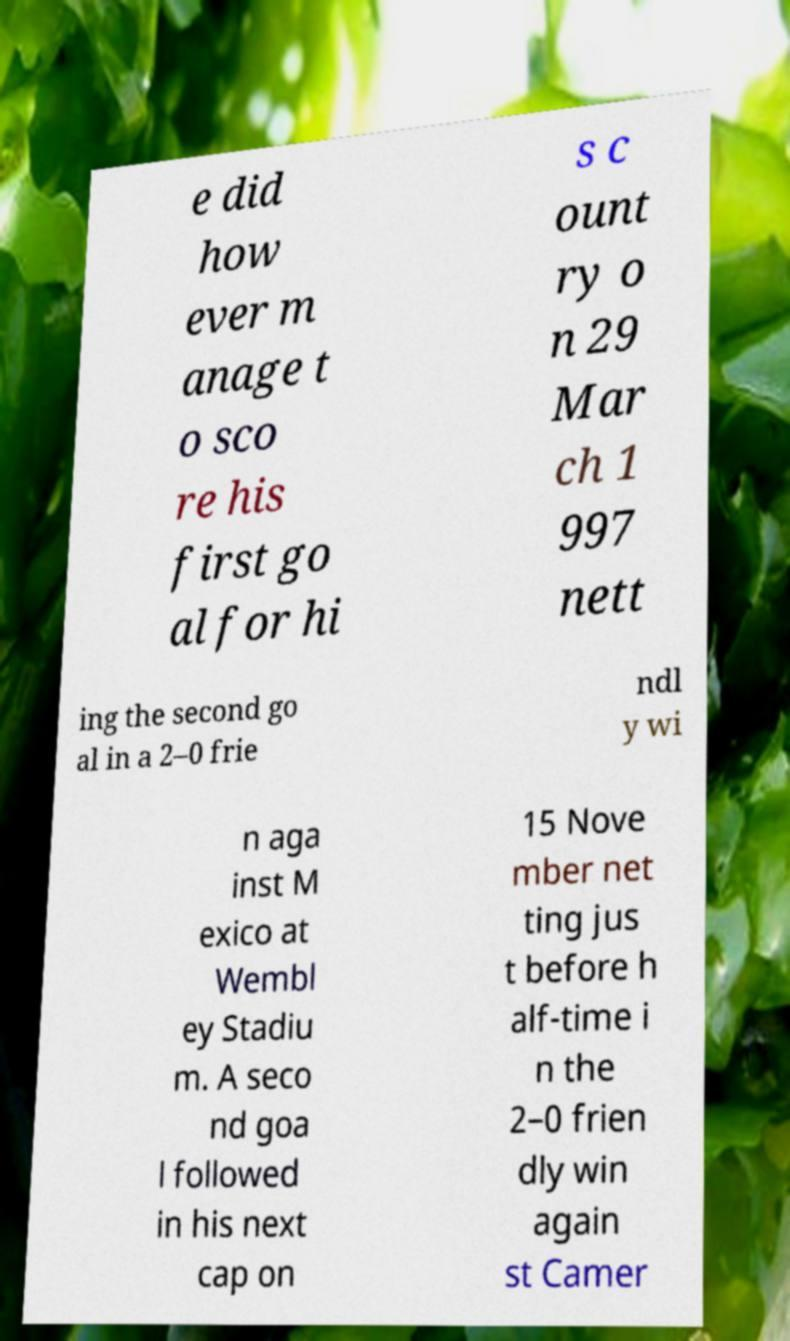For documentation purposes, I need the text within this image transcribed. Could you provide that? e did how ever m anage t o sco re his first go al for hi s c ount ry o n 29 Mar ch 1 997 nett ing the second go al in a 2–0 frie ndl y wi n aga inst M exico at Wembl ey Stadiu m. A seco nd goa l followed in his next cap on 15 Nove mber net ting jus t before h alf-time i n the 2–0 frien dly win again st Camer 